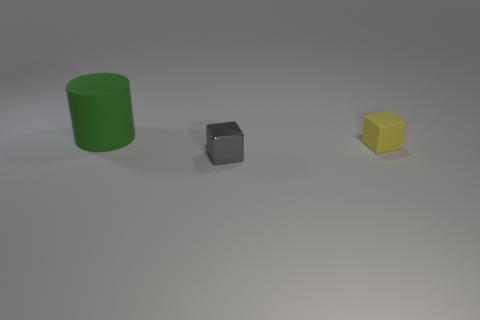What is the relative size of the green object compared to the other objects? The green object appears to be the largest among the visible objects when compared to the yellow and grey blocks, which seem significantly smaller. 